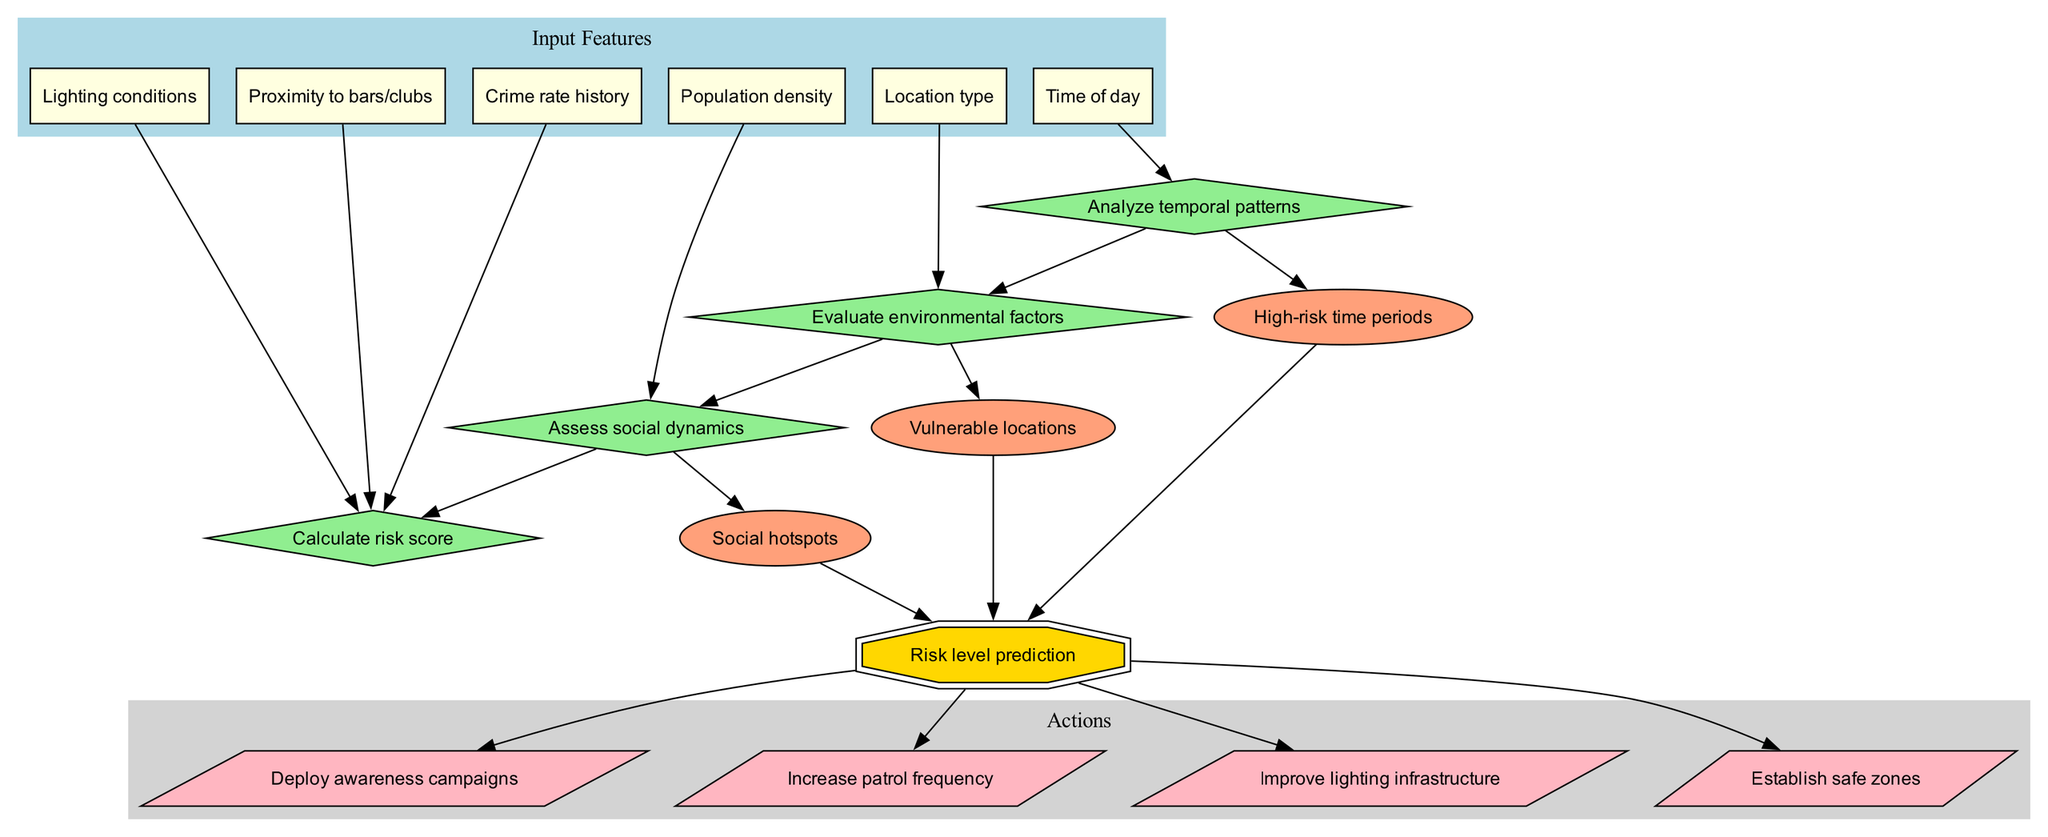What are the input features listed in the diagram? The diagram lists six input features: "Time of day", "Location type", "Population density", "Lighting conditions", "Proximity to bars/clubs", and "Crime rate history".
Answer: Time of day, Location type, Population density, Lighting conditions, Proximity to bars/clubs, Crime rate history How many decision nodes are there in the diagram? There are four decision nodes displayed: "Analyze temporal patterns", "Evaluate environmental factors", "Assess social dynamics", and "Calculate risk score".
Answer: 4 What is the final output of the machine learning model? The final output node clearly indicates the risk level prediction as the ultimate result of the model.
Answer: Risk level prediction Which input feature connects directly to the first decision node? The first decision node is connected directly by "Time of day", indicating that this feature initiates the decision-making process.
Answer: Time of day What is the relationship between intermediate outputs and the final output? Each intermediate output ("High-risk time periods", "Vulnerable locations", "Social hotspots") has an edge connecting it to the final output, indicating they feed into the overall risk level prediction.
Answer: Direct connection Which decision node evaluates environmental factors? The decision node that evaluates environmental factors is specifically labeled as "Evaluate environmental factors", indicating its role in the analysis.
Answer: Evaluate environmental factors How many actions are suggested based on the risk level prediction? The diagram suggests four actions stemming from the risk level prediction, namely "Deploy awareness campaigns", "Increase patrol frequency", "Improve lighting infrastructure", and "Establish safe zones".
Answer: 4 What are the specific intermediate outputs defined in the model? The diagram outlines three intermediate outputs: "High-risk time periods", "Vulnerable locations", and "Social hotspots", indicating specific areas of concern derived from the decision-making process.
Answer: High-risk time periods, Vulnerable locations, Social hotspots What type of connection exists between the final output and the actions? The connection between the final output and the actions is depicted as direct edges leading from the "Risk level prediction" to each of the action nodes, indicating a straightforward dependence on the prediction.
Answer: Direct edges 